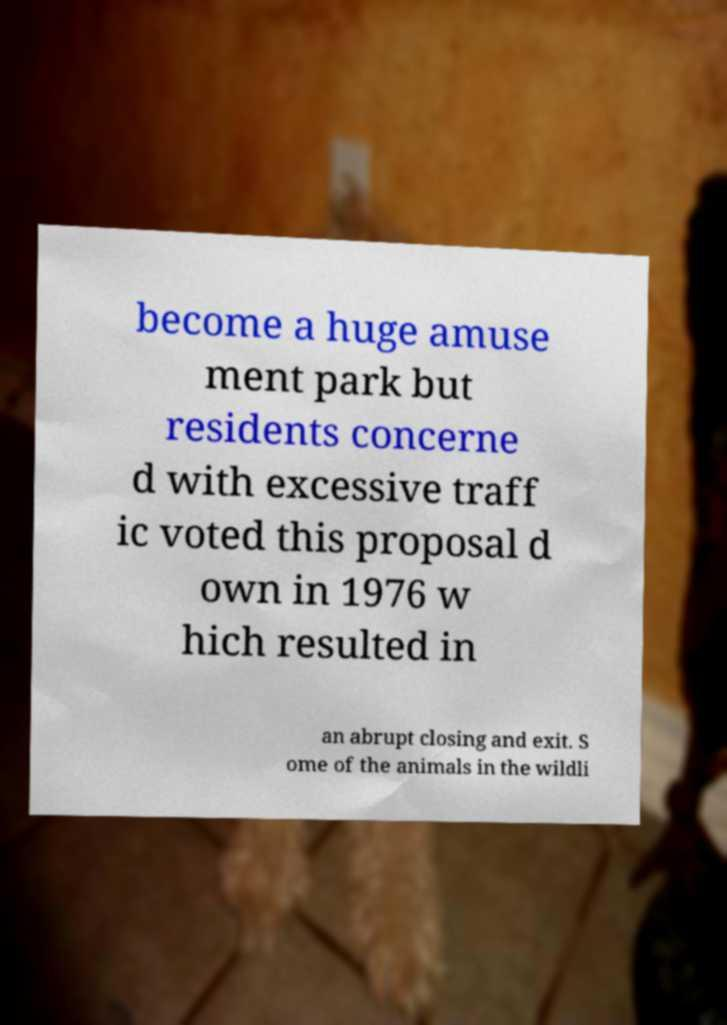What messages or text are displayed in this image? I need them in a readable, typed format. become a huge amuse ment park but residents concerne d with excessive traff ic voted this proposal d own in 1976 w hich resulted in an abrupt closing and exit. S ome of the animals in the wildli 